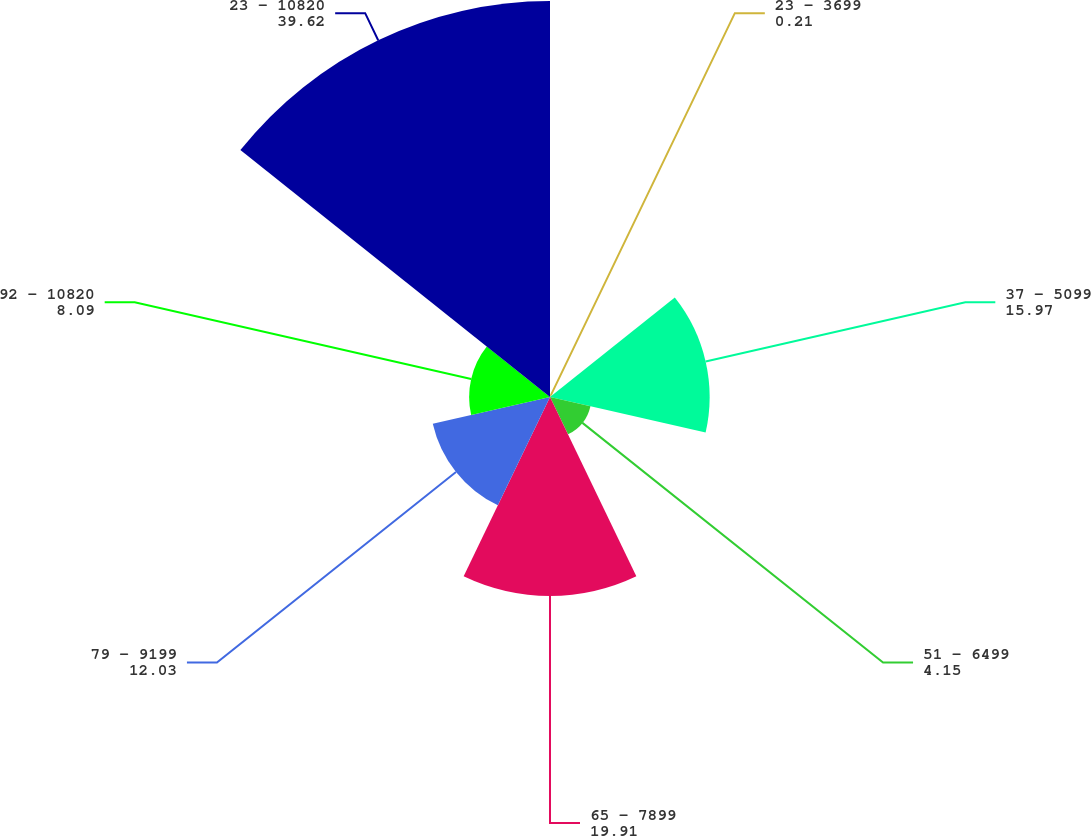Convert chart to OTSL. <chart><loc_0><loc_0><loc_500><loc_500><pie_chart><fcel>23 - 3699<fcel>37 - 5099<fcel>51 - 6499<fcel>65 - 7899<fcel>79 - 9199<fcel>92 - 10820<fcel>23 - 10820<nl><fcel>0.21%<fcel>15.97%<fcel>4.15%<fcel>19.91%<fcel>12.03%<fcel>8.09%<fcel>39.62%<nl></chart> 